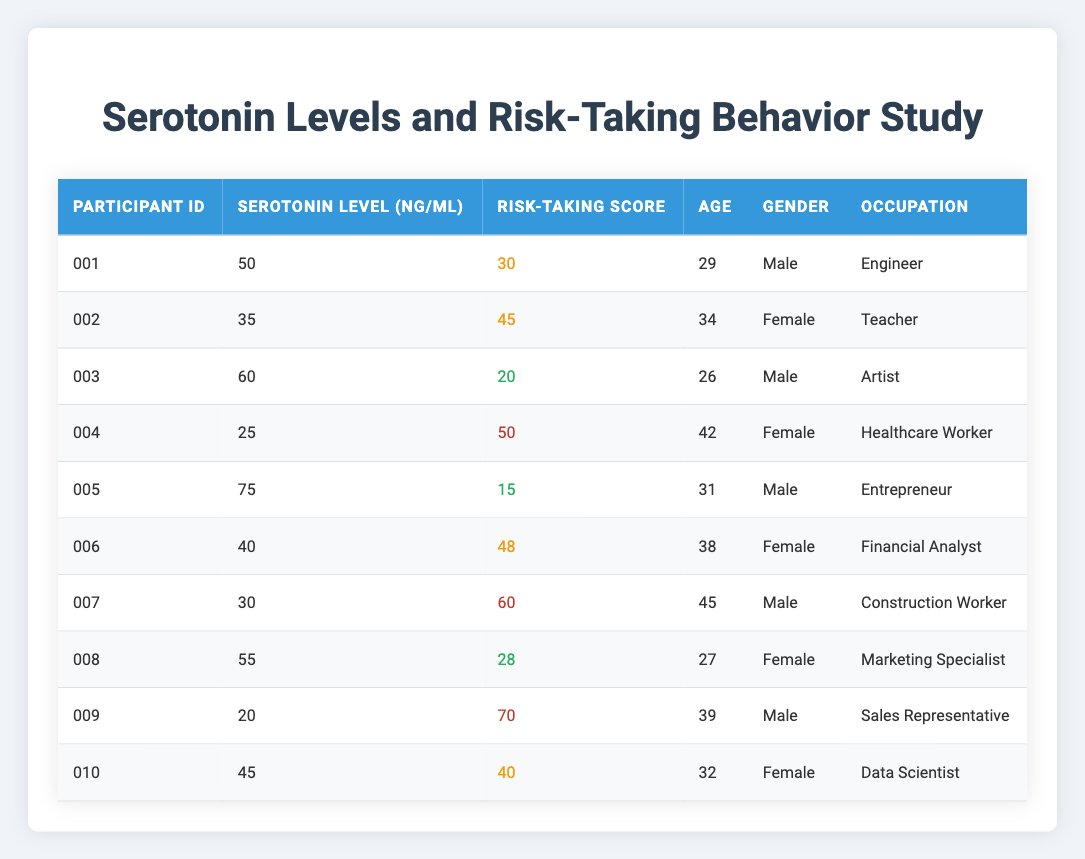What is the highest serotonin level recorded in the table? Looking through the "Serotonin Level (ng/ml)" column, the highest value is 75, associated with participant ID 005.
Answer: 75 Which participant has the lowest risk-taking score? By examining the "Risk-Taking Score" column, participant ID 005 has the lowest score of 15.
Answer: 15 How many male participants are in the study? Counting the entries in the "Gender" column, there are 5 males: participant IDs 001, 003, 005, 007, and 009.
Answer: 5 What is the average risk-taking score of all participants? The risk-taking scores are summed up as (30 + 45 + 20 + 50 + 15 + 48 + 60 + 28 + 70 + 40) = 408. Since there are 10 participants, the average is 408/10 = 40.8.
Answer: 40.8 Is there a participant with a serotonin level above 70 and a risk-taking score below 20? Looking at the entries, participant ID 005 has a serotonin level of 75 and a risk-taking score of 15, confirming that this condition is met.
Answer: Yes What is the difference between the highest and lowest serotonin levels in the table? The highest serotonin level is 75 (participant ID 005) and the lowest is 20 (participant ID 009). The difference is 75 - 20 = 55.
Answer: 55 What percentage of participants took medium risks? There are 4 participants with a risk-taking score categorized as medium: IDs 001, 002, 006, and 010. Therefore, the percentage of medium-risk takers is (4/10) * 100 = 40%.
Answer: 40% Which age group has the highest average serotonin level? The ages of participants with serotonin levels are: 29 (50 ng/ml), 34 (35 ng/ml), 26 (60 ng/ml), 42 (25 ng/ml), 31 (75 ng/ml), 38 (40 ng/ml), 45 (30 ng/ml), 27 (55 ng/ml), 39 (20 ng/ml), and 32 (45 ng/ml). The average serotonin levels for age groups can be calculated, and the highest average serotonin level is found in the group aged 26 with an average of 60.
Answer: 60 Do females tend to have higher risk-taking scores compared to males in this study? By comparing the average risk-taking scores, females (45 + 50 + 48 + 28 + 40)/5 = 42.2 and males (30 + 45 + 20 + 60 + 70)/5 = 45. The averages show that males tend to have higher scores.
Answer: No What is the median risk-taking score of the participants? First, the risk-taking scores must be sorted: 15, 20, 28, 30, 40, 45, 48, 50, 60, 70. With 10 scores, the median is the average of the 5th and 6th values: (40 + 45)/2 = 42.5.
Answer: 42.5 